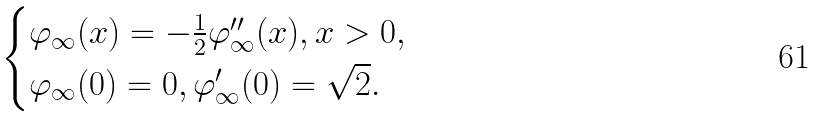Convert formula to latex. <formula><loc_0><loc_0><loc_500><loc_500>\begin{cases} \varphi _ { \infty } ( x ) = - \frac { 1 } { 2 } \varphi _ { \infty } ^ { \prime \prime } ( x ) , x > 0 , \\ \varphi _ { \infty } ( 0 ) = 0 , \varphi _ { \infty } ^ { \prime } ( 0 ) = \sqrt { 2 } . \end{cases}</formula> 